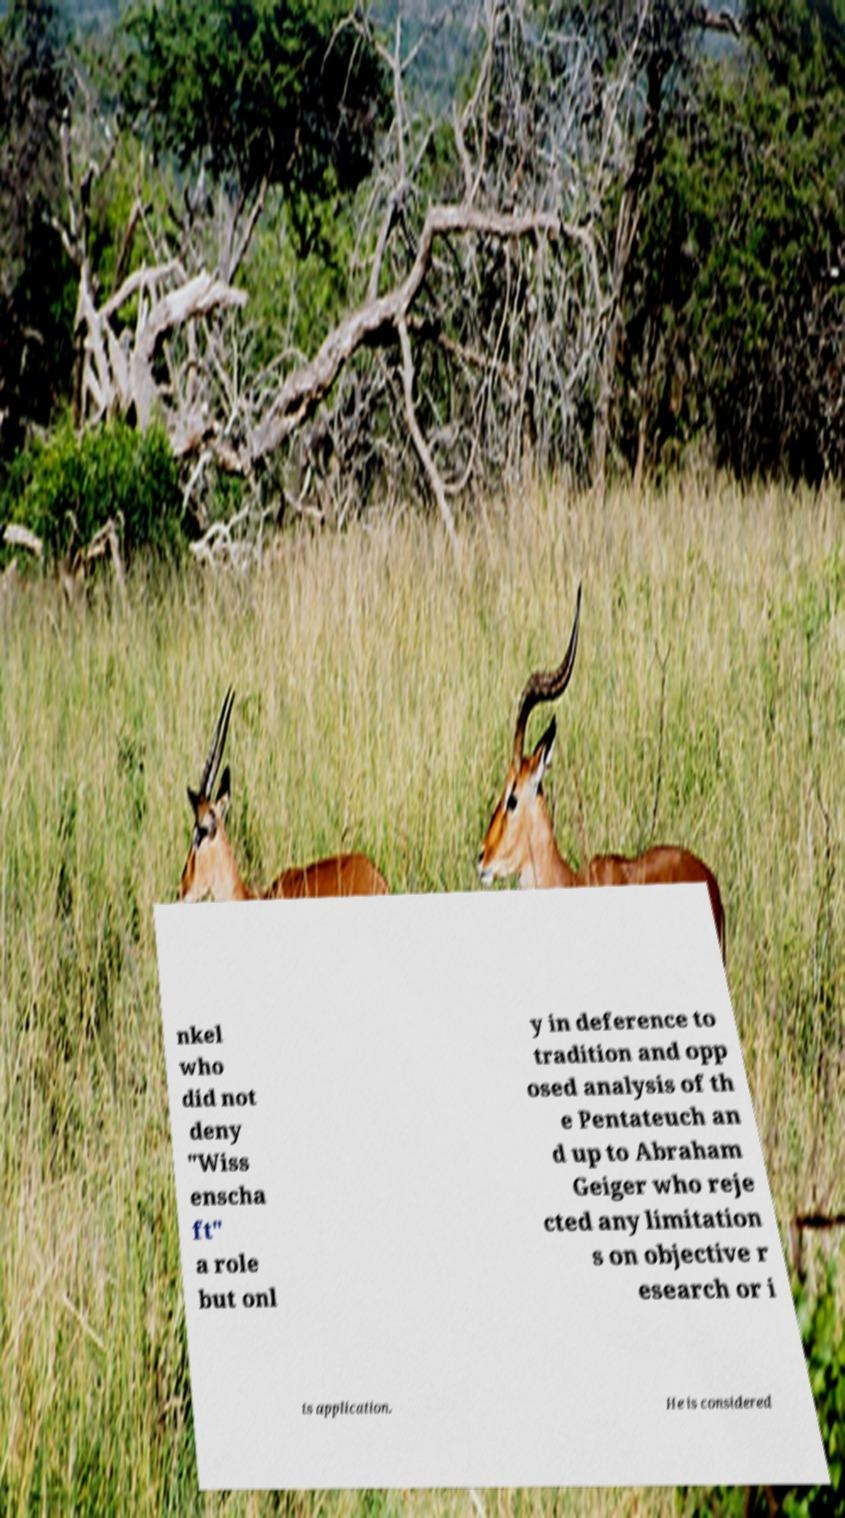Can you read and provide the text displayed in the image?This photo seems to have some interesting text. Can you extract and type it out for me? nkel who did not deny "Wiss enscha ft" a role but onl y in deference to tradition and opp osed analysis of th e Pentateuch an d up to Abraham Geiger who reje cted any limitation s on objective r esearch or i ts application. He is considered 